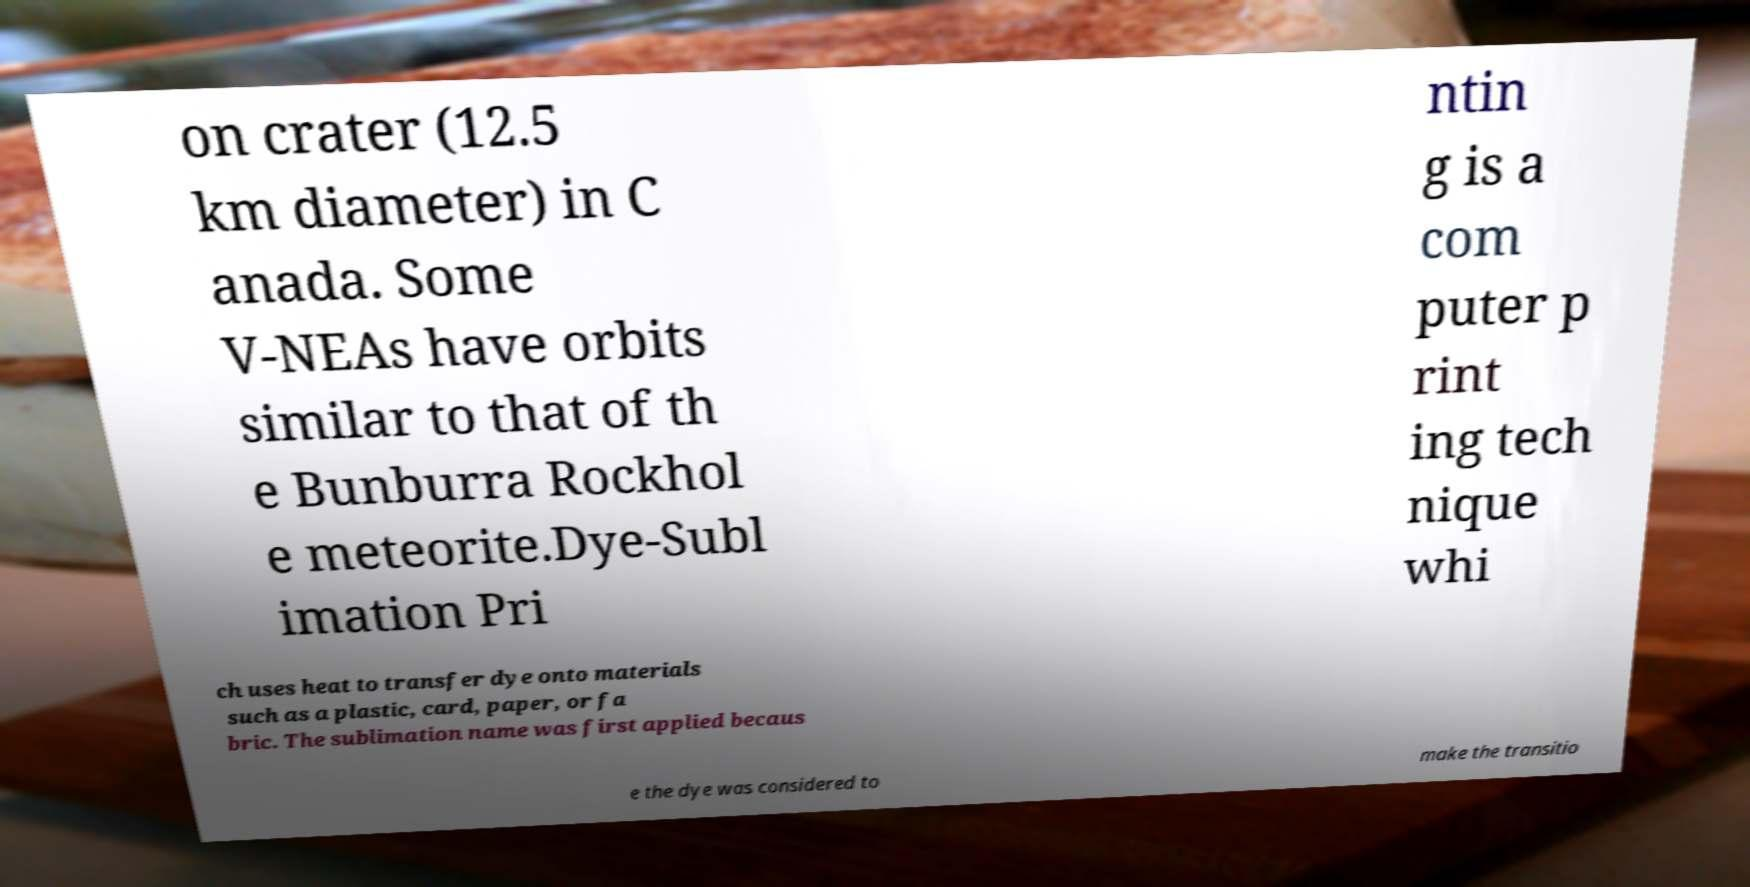Please read and relay the text visible in this image. What does it say? on crater (12.5 km diameter) in C anada. Some V-NEAs have orbits similar to that of th e Bunburra Rockhol e meteorite.Dye-Subl imation Pri ntin g is a com puter p rint ing tech nique whi ch uses heat to transfer dye onto materials such as a plastic, card, paper, or fa bric. The sublimation name was first applied becaus e the dye was considered to make the transitio 